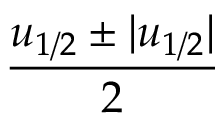<formula> <loc_0><loc_0><loc_500><loc_500>\frac { u _ { 1 / 2 } \pm | u _ { 1 / 2 } | } { 2 }</formula> 